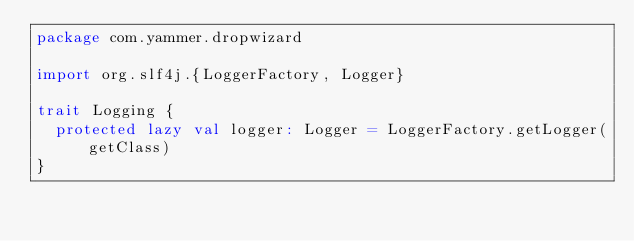Convert code to text. <code><loc_0><loc_0><loc_500><loc_500><_Scala_>package com.yammer.dropwizard

import org.slf4j.{LoggerFactory, Logger}

trait Logging {
  protected lazy val logger: Logger = LoggerFactory.getLogger(getClass)
}
</code> 